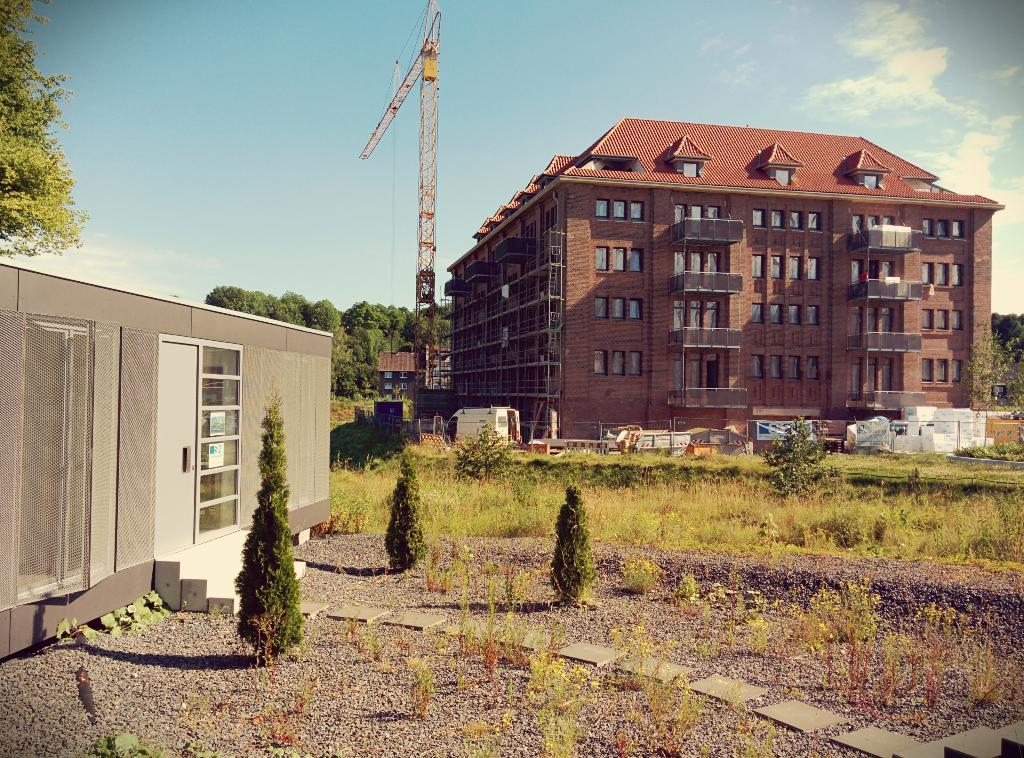What type of structures can be seen in the image? There are buildings, a house, and towers in the image. What is visible on the ground in the image? There are objects on the ground in the image. What type of vegetation is present in the image? There are trees, grass, and plants in the image. What part of the natural environment is visible in the image? The ground, trees, grass, and plants are visible in the image. What is visible in the sky in the image? The sky is visible in the image. What type of thread is being used to decorate the crown in the image? There is no crown present in the image, so it is not possible to answer that question. 